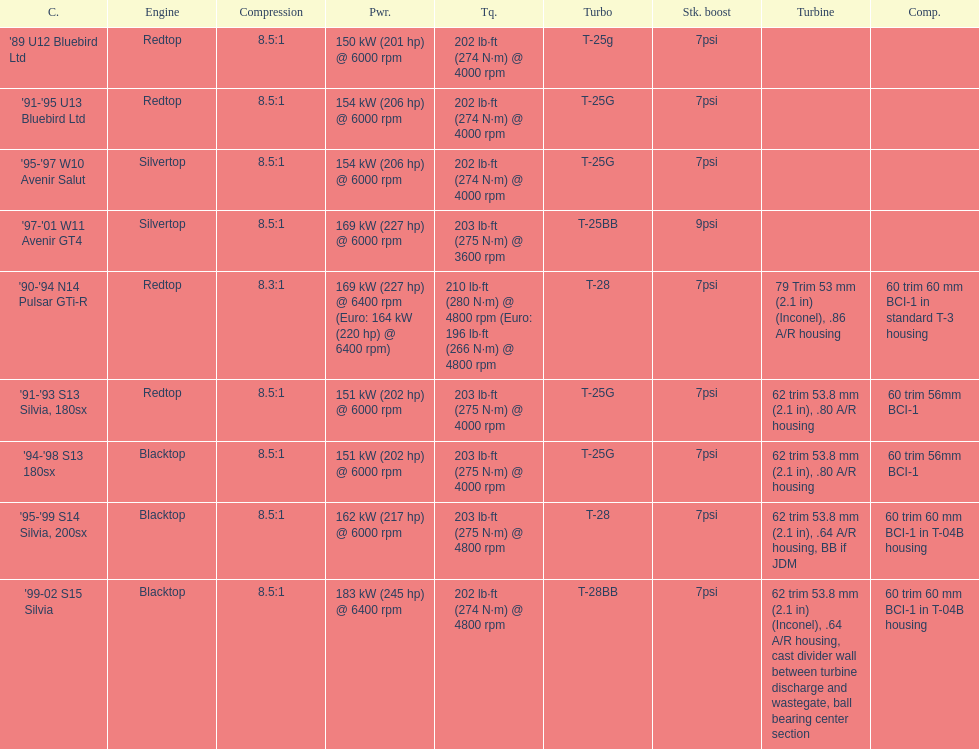Which automobile has a standard boost of over 7psi? '97-'01 W11 Avenir GT4. 